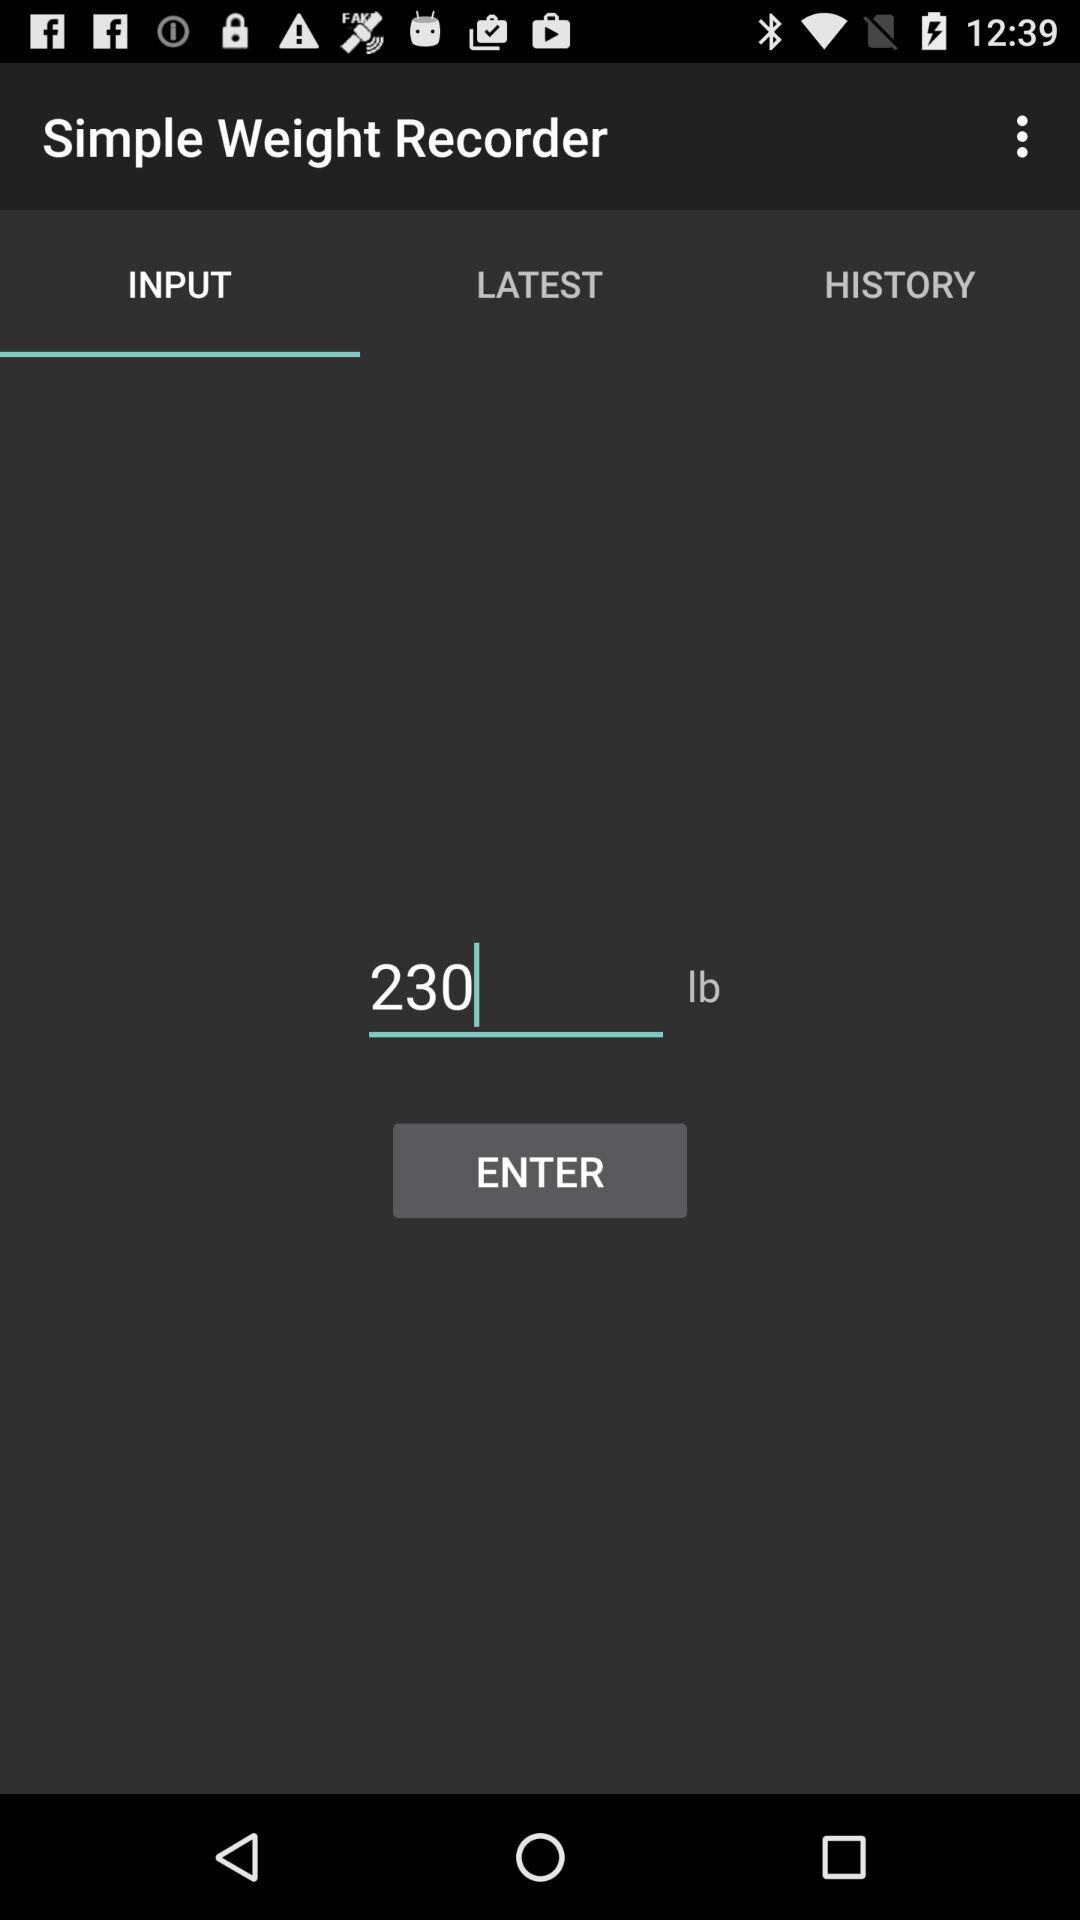On which tab am I now? You are now on the "INPUT" tab. 